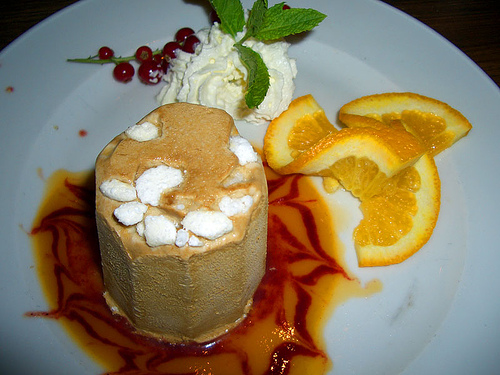<image>What kind of seeds are those? I don't know what kind of seeds those are. They could be lemon, pomegranate, orange, cherry, grape, or cranberry seeds. What race is the person holding the food? It is uncertain what race the person holding the food is. It is also not clearly visible. What is brown in the image? I am not sure what is brown in the image. It can be an ice cream, desert or sauce. What kind of seeds are those? I am not sure what kind of seeds are those. They can be lemon, pomegranate, orange, cherry, grape, cranberry or pomegranate seeds. What race is the person holding the food? I don't know what race is the person holding the food. There are multiple possibilities, such as caucasian, asian or white. What is brown in the image? I don't know what is brown in the image. It can be ice cream, desert or sauce. 